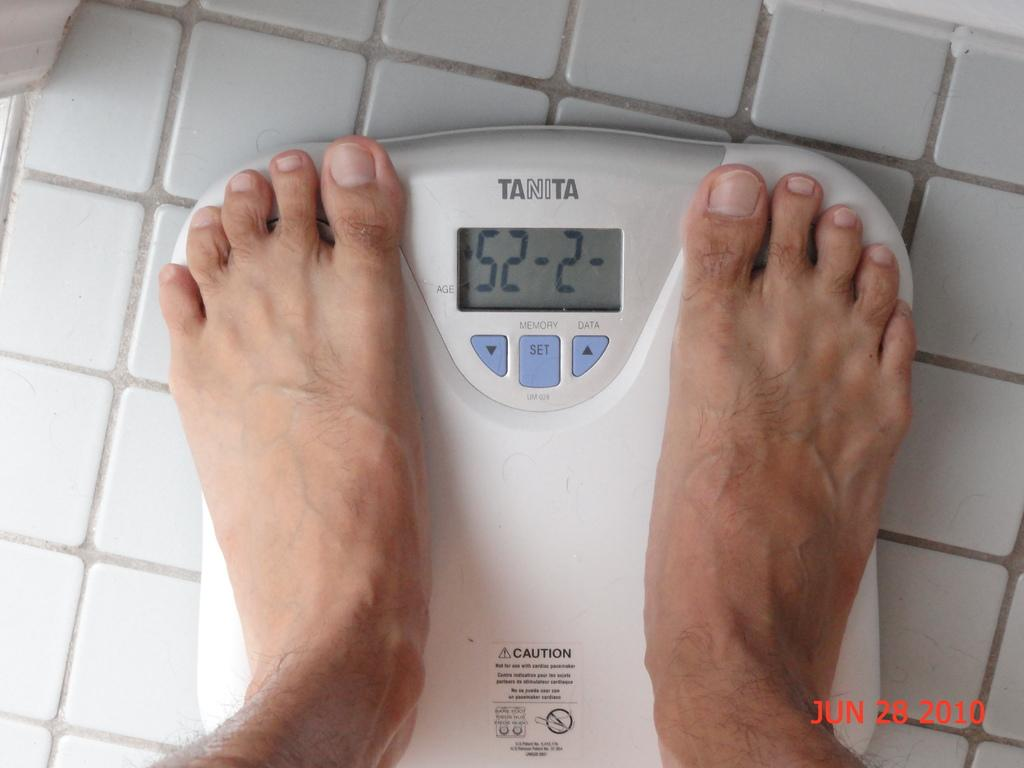What type of flooring is visible in the image? There is a tiled floor in the image. What exercise equipment is present on the floor? There is a weight machine on the floor. Whose legs can be seen on the weight machine? A person's legs are on the weight machine. What type of beast can be seen reciting a verse on the tiled floor in the image? There is no beast or verse present in the image; it features a weight machine with a person's legs on it. 